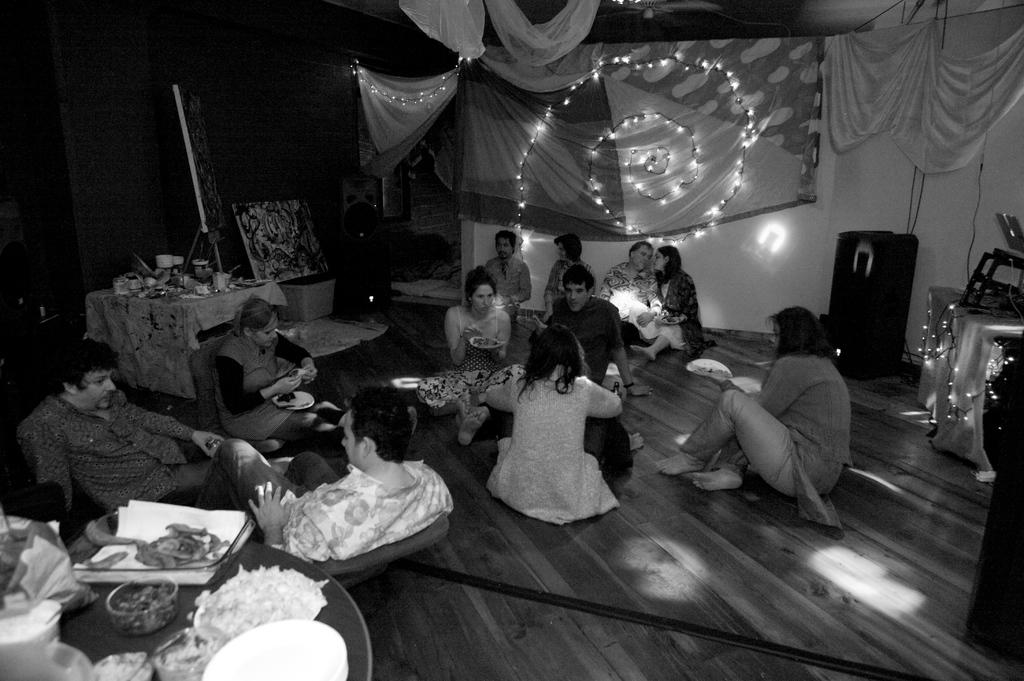What is the color scheme of the image? The image is black and white. Who or what can be seen in the image? There are people in the image. What type of fabric is present in the image? There are tablecloths in the image. What type of illumination is visible in the image? There are lights in the image. What type of stationery items are present in the image? There are papers in the image. What type of dishware is present in the image? There are plates in the image. What other objects can be seen in the image? There are additional objects in the image. Can you tell me how many quarters are visible in the image? There are no quarters present in the image. What type of water body can be seen in the image? There is no lake or any other water body present in the image. 